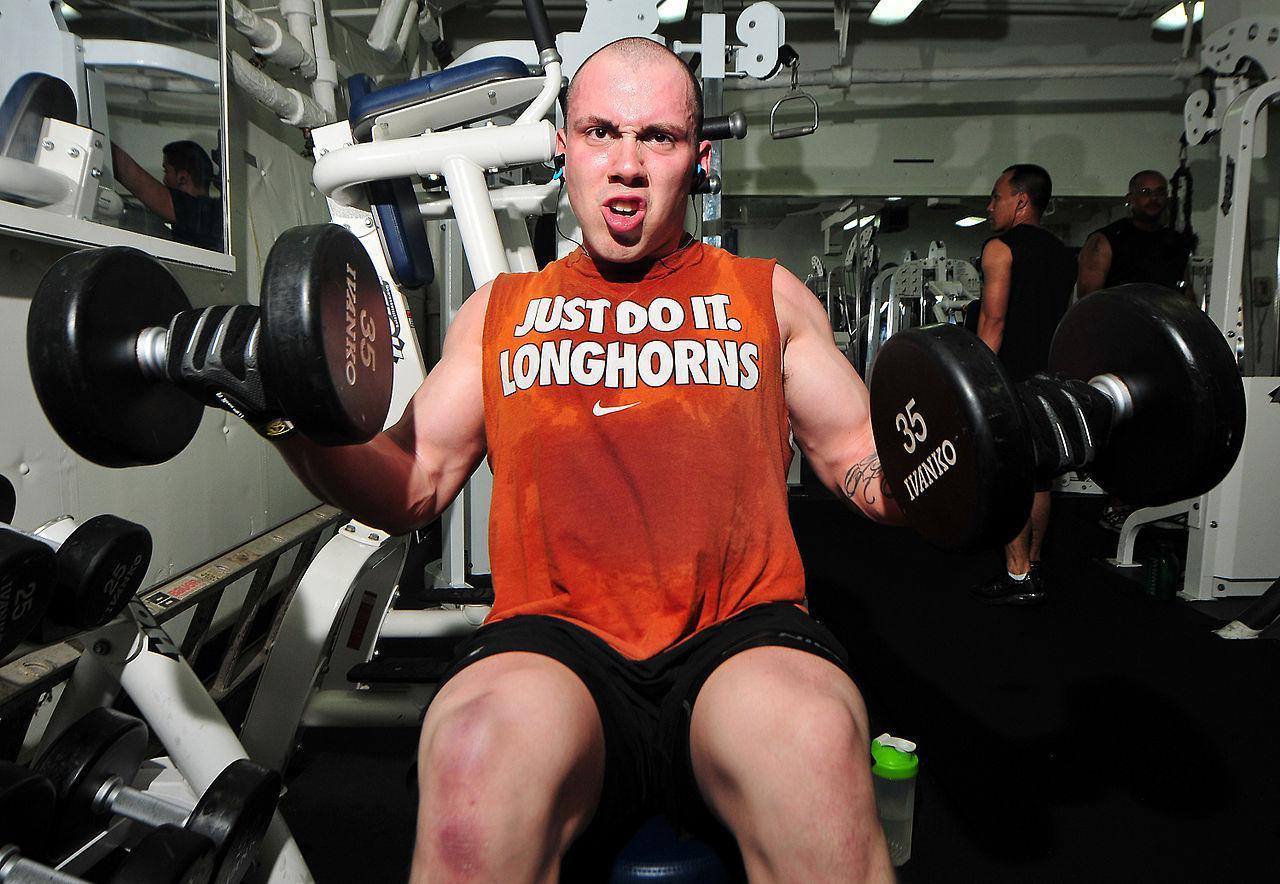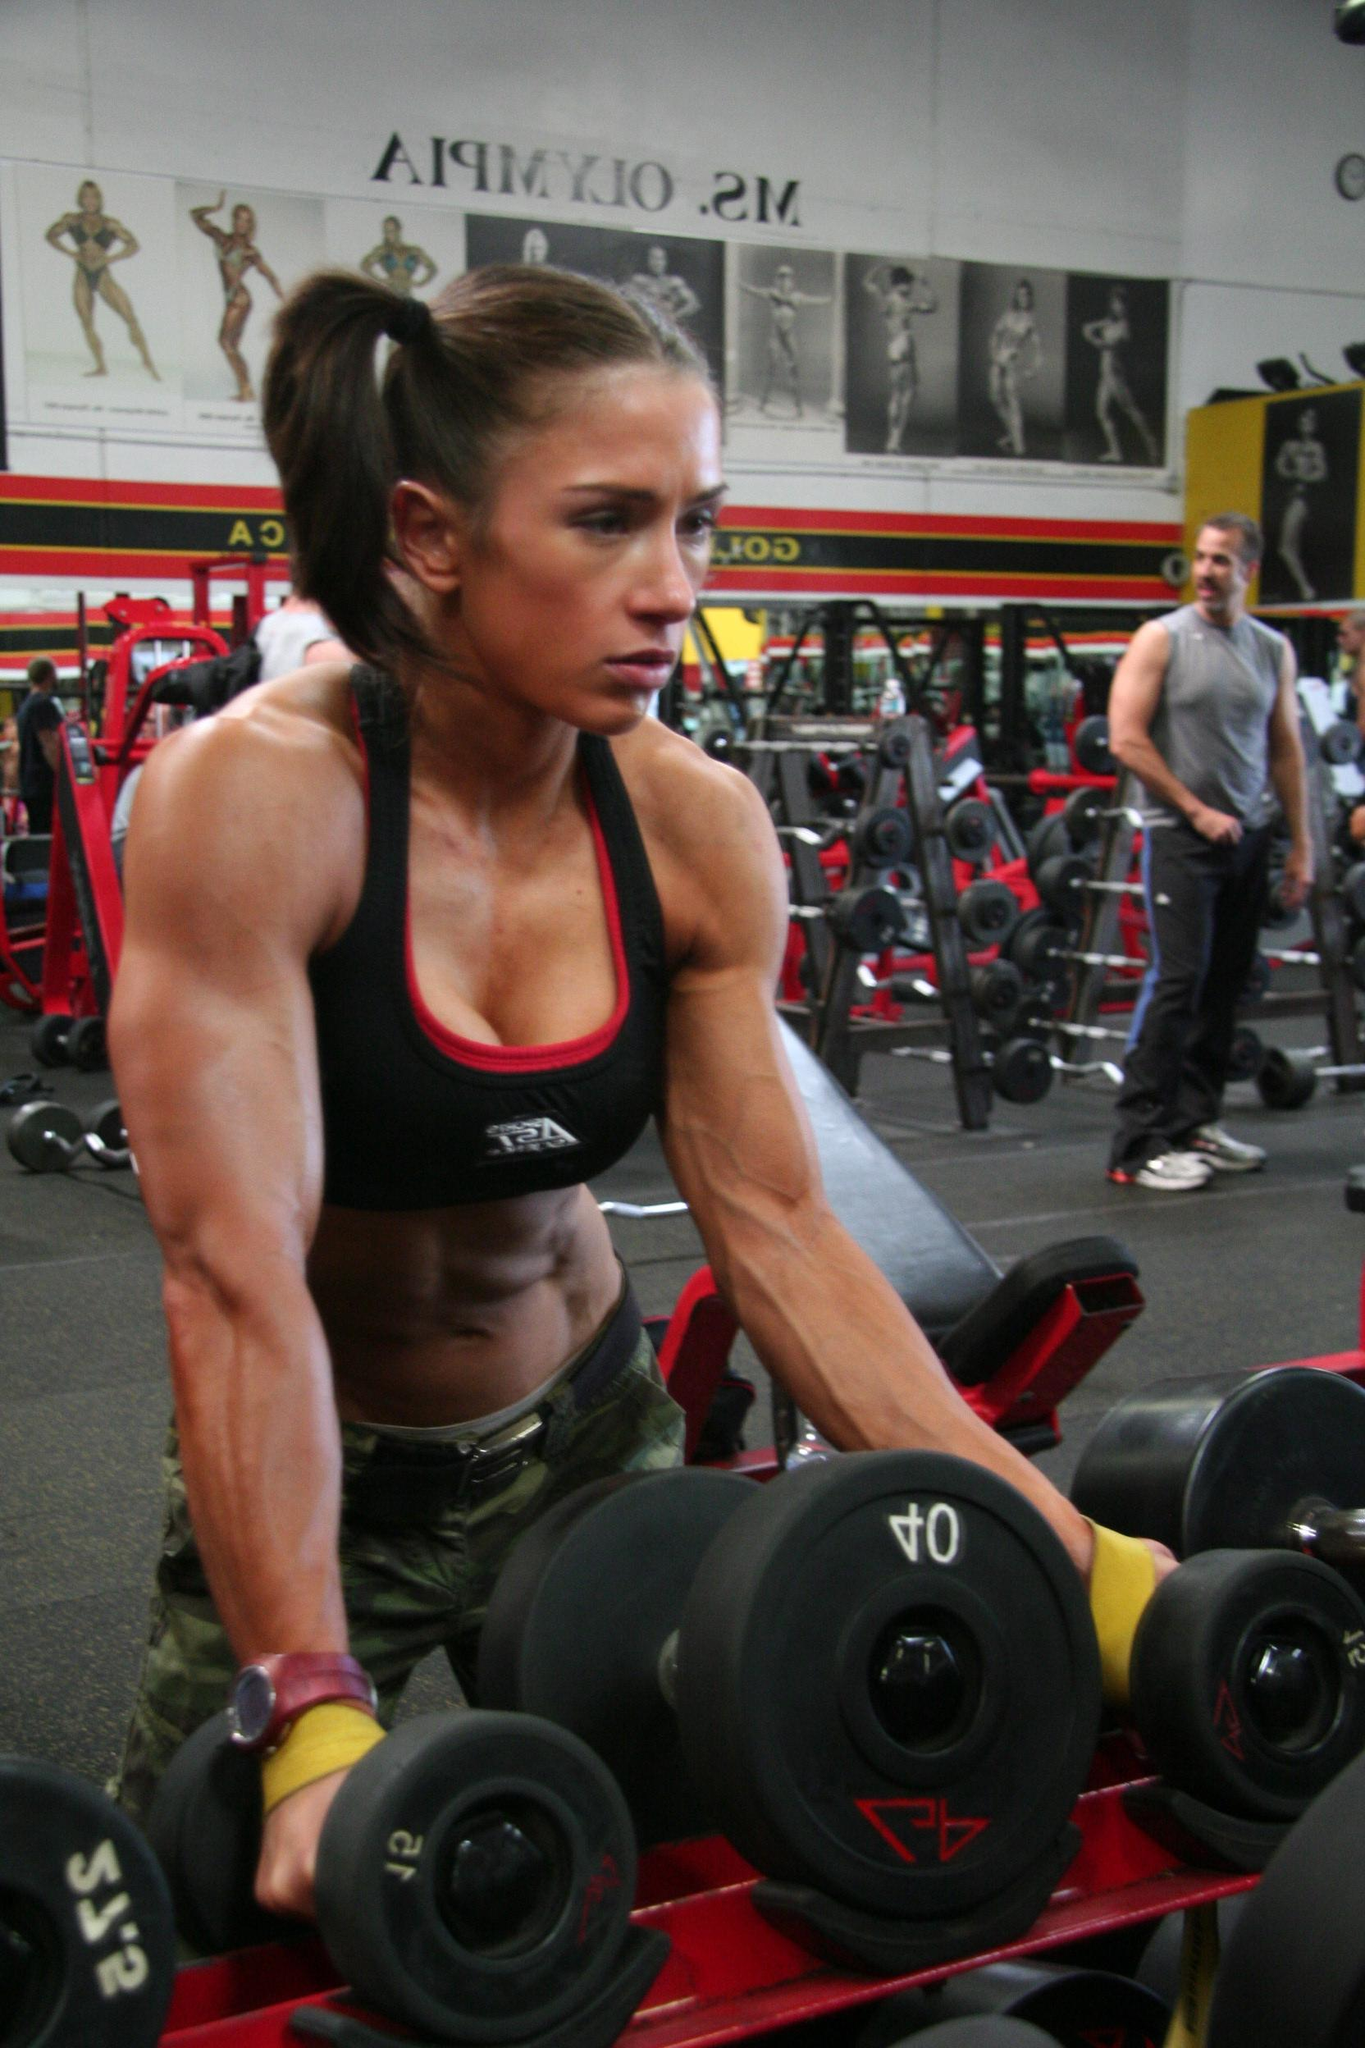The first image is the image on the left, the second image is the image on the right. Given the left and right images, does the statement "At least one image features a woman." hold true? Answer yes or no. Yes. 